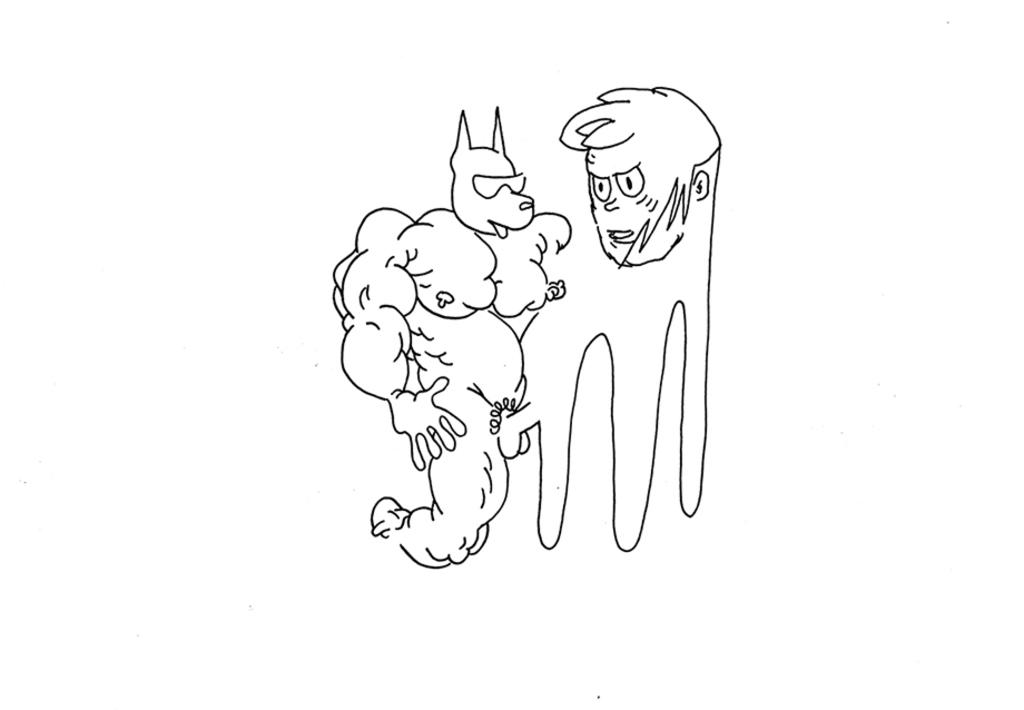What type of artwork is the image? The image is a sketch painting. What subjects are depicted in the painting? There are persons depicted in the painting. Who is the owner of the corn depicted in the image? There is no corn present in the image, so it is not possible to determine the owner. 